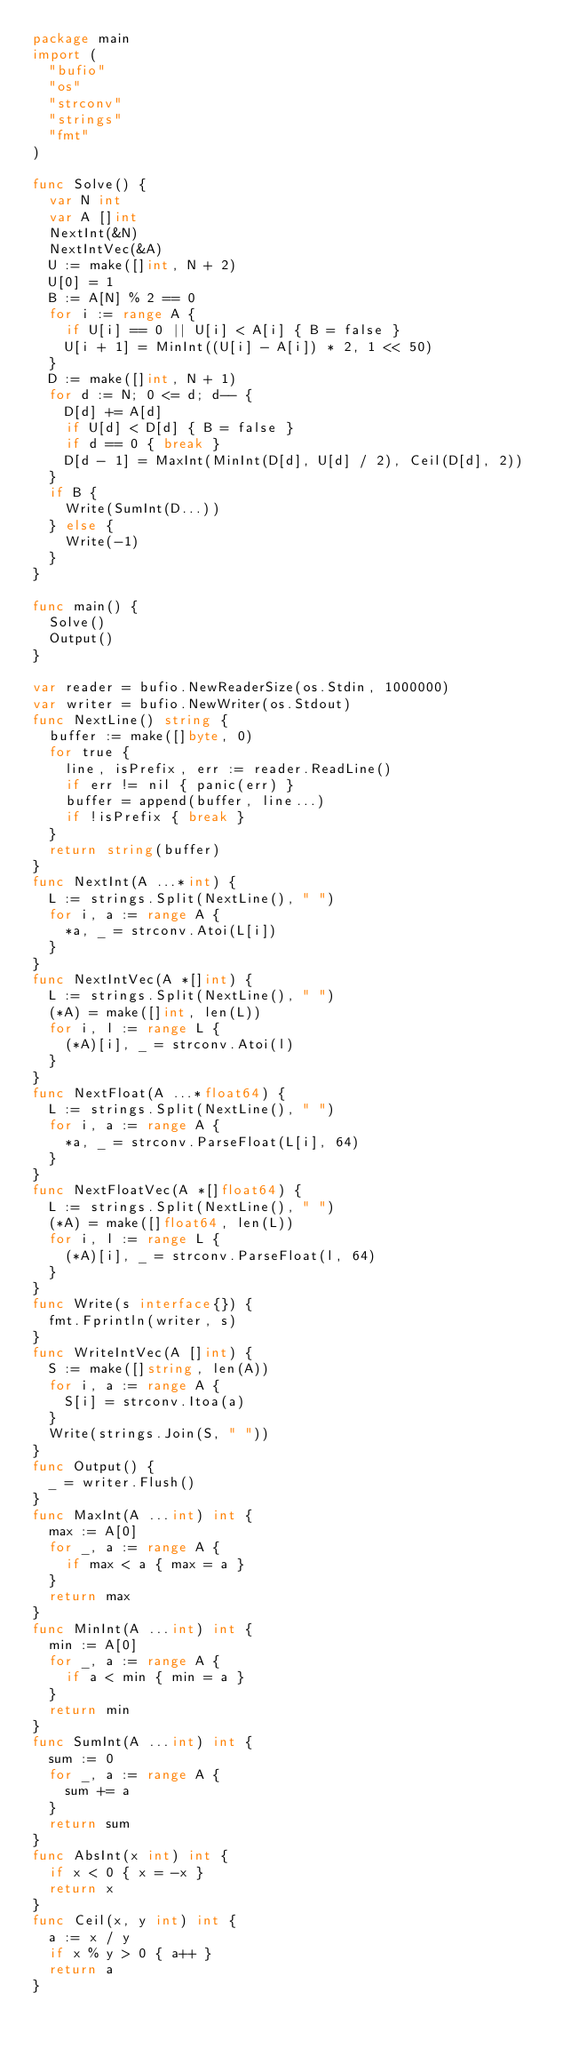<code> <loc_0><loc_0><loc_500><loc_500><_Go_>package main
import (
  "bufio"
  "os"
  "strconv"
  "strings"
  "fmt"
)

func Solve() {
  var N int
  var A []int
  NextInt(&N)
  NextIntVec(&A)
  U := make([]int, N + 2)
  U[0] = 1
  B := A[N] % 2 == 0
  for i := range A {
    if U[i] == 0 || U[i] < A[i] { B = false }
    U[i + 1] = MinInt((U[i] - A[i]) * 2, 1 << 50)
  }
  D := make([]int, N + 1)
  for d := N; 0 <= d; d-- {
    D[d] += A[d]
    if U[d] < D[d] { B = false }
    if d == 0 { break }
    D[d - 1] = MaxInt(MinInt(D[d], U[d] / 2), Ceil(D[d], 2))
  }
  if B {
    Write(SumInt(D...))
  } else {
    Write(-1)
  }
}

func main() {
  Solve()
  Output()
}

var reader = bufio.NewReaderSize(os.Stdin, 1000000)
var writer = bufio.NewWriter(os.Stdout)
func NextLine() string {
  buffer := make([]byte, 0)
  for true {
    line, isPrefix, err := reader.ReadLine()
    if err != nil { panic(err) }
    buffer = append(buffer, line...)
    if !isPrefix { break }
  }
  return string(buffer)
}
func NextInt(A ...*int) {
  L := strings.Split(NextLine(), " ")
  for i, a := range A {
    *a, _ = strconv.Atoi(L[i])
  }
}
func NextIntVec(A *[]int) {
  L := strings.Split(NextLine(), " ")
  (*A) = make([]int, len(L))
  for i, l := range L {
    (*A)[i], _ = strconv.Atoi(l)
  }
}
func NextFloat(A ...*float64) {
  L := strings.Split(NextLine(), " ")
  for i, a := range A {
    *a, _ = strconv.ParseFloat(L[i], 64)
  }
}
func NextFloatVec(A *[]float64) {
  L := strings.Split(NextLine(), " ")
  (*A) = make([]float64, len(L))
  for i, l := range L {
    (*A)[i], _ = strconv.ParseFloat(l, 64)
  }
}
func Write(s interface{}) {
  fmt.Fprintln(writer, s)
}
func WriteIntVec(A []int) {
  S := make([]string, len(A))
  for i, a := range A {
    S[i] = strconv.Itoa(a)
  }
  Write(strings.Join(S, " "))
}
func Output() {
  _ = writer.Flush()
}
func MaxInt(A ...int) int {
  max := A[0]
  for _, a := range A {
    if max < a { max = a }
  }
  return max
}
func MinInt(A ...int) int {
  min := A[0]
  for _, a := range A {
    if a < min { min = a }
  }
  return min
}
func SumInt(A ...int) int {
  sum := 0
  for _, a := range A {
    sum += a
  }
  return sum
}
func AbsInt(x int) int {
  if x < 0 { x = -x }
  return x
}
func Ceil(x, y int) int {
  a := x / y
  if x % y > 0 { a++ }
  return a
}</code> 